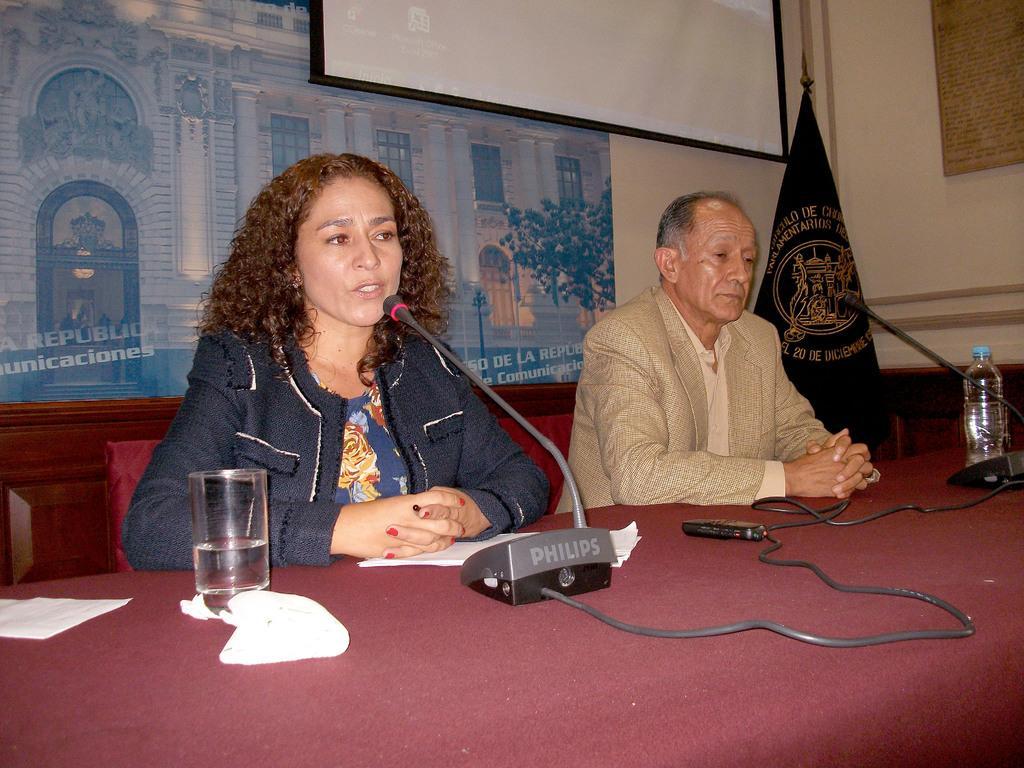In one or two sentences, can you explain what this image depicts? As we can see in the image there is a wall, banner, screen and two people sitting on chairs and there is a table. On table there is a mic, glass and bottle. 